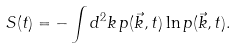<formula> <loc_0><loc_0><loc_500><loc_500>S ( t ) = - \int d ^ { 2 } k \, p ( \vec { k } , t ) \ln p ( \vec { k } , t ) .</formula> 